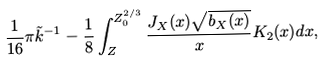<formula> <loc_0><loc_0><loc_500><loc_500>\frac { 1 } { 1 6 } \pi \tilde { k } ^ { - 1 } - \frac { 1 } { 8 } \int _ { Z } ^ { Z _ { 0 } ^ { 2 / 3 } } \frac { J _ { X } ( x ) \sqrt { b _ { X } ( x ) } } { x } K _ { 2 } ( x ) d x ,</formula> 